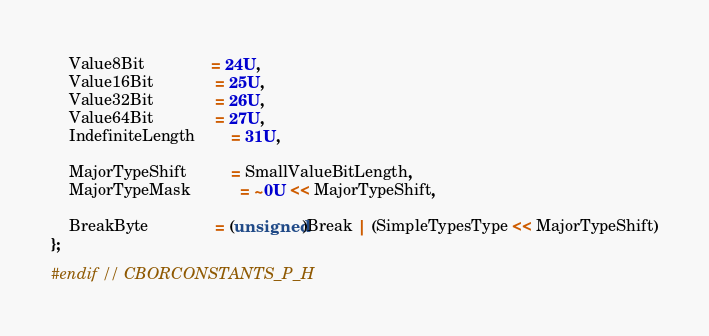Convert code to text. <code><loc_0><loc_0><loc_500><loc_500><_C_>    Value8Bit               = 24U,
    Value16Bit              = 25U,
    Value32Bit              = 26U,
    Value64Bit              = 27U,
    IndefiniteLength        = 31U,

    MajorTypeShift          = SmallValueBitLength,
    MajorTypeMask           = ~0U << MajorTypeShift,

    BreakByte               = (unsigned)Break | (SimpleTypesType << MajorTypeShift)
};

#endif // CBORCONSTANTS_P_H

</code> 